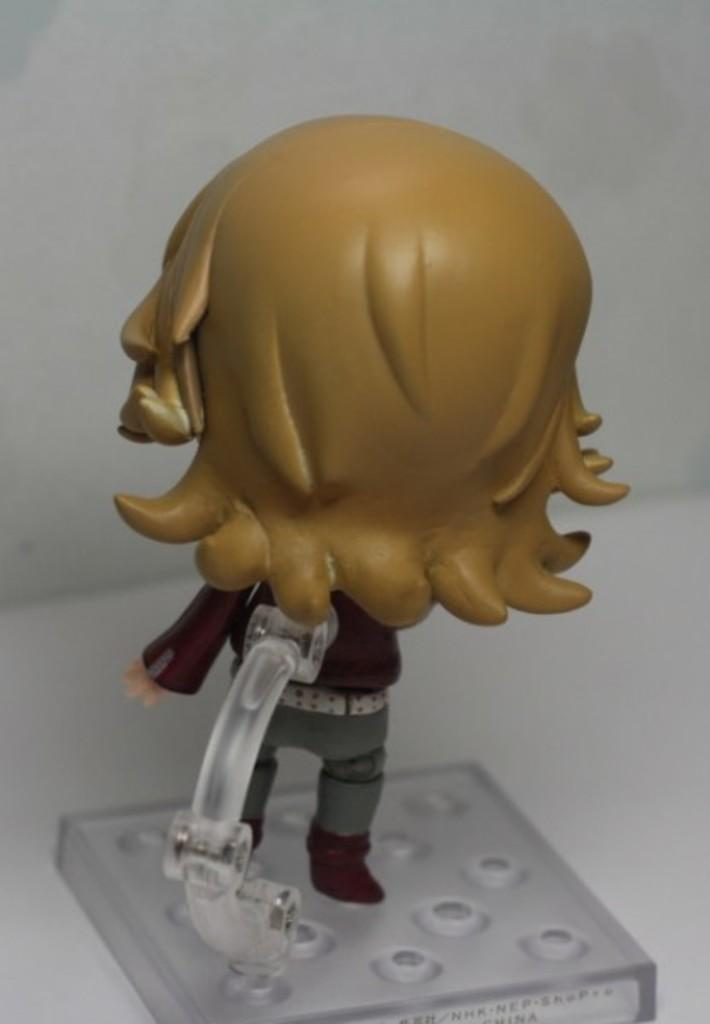What object can be seen in the image? There is a toy in the image. Where is the toy located? The toy is on a glass. What type of battle is taking place between the toy and the bee in the image? There is no battle or bee present in the image; it only features a toy on a glass. 